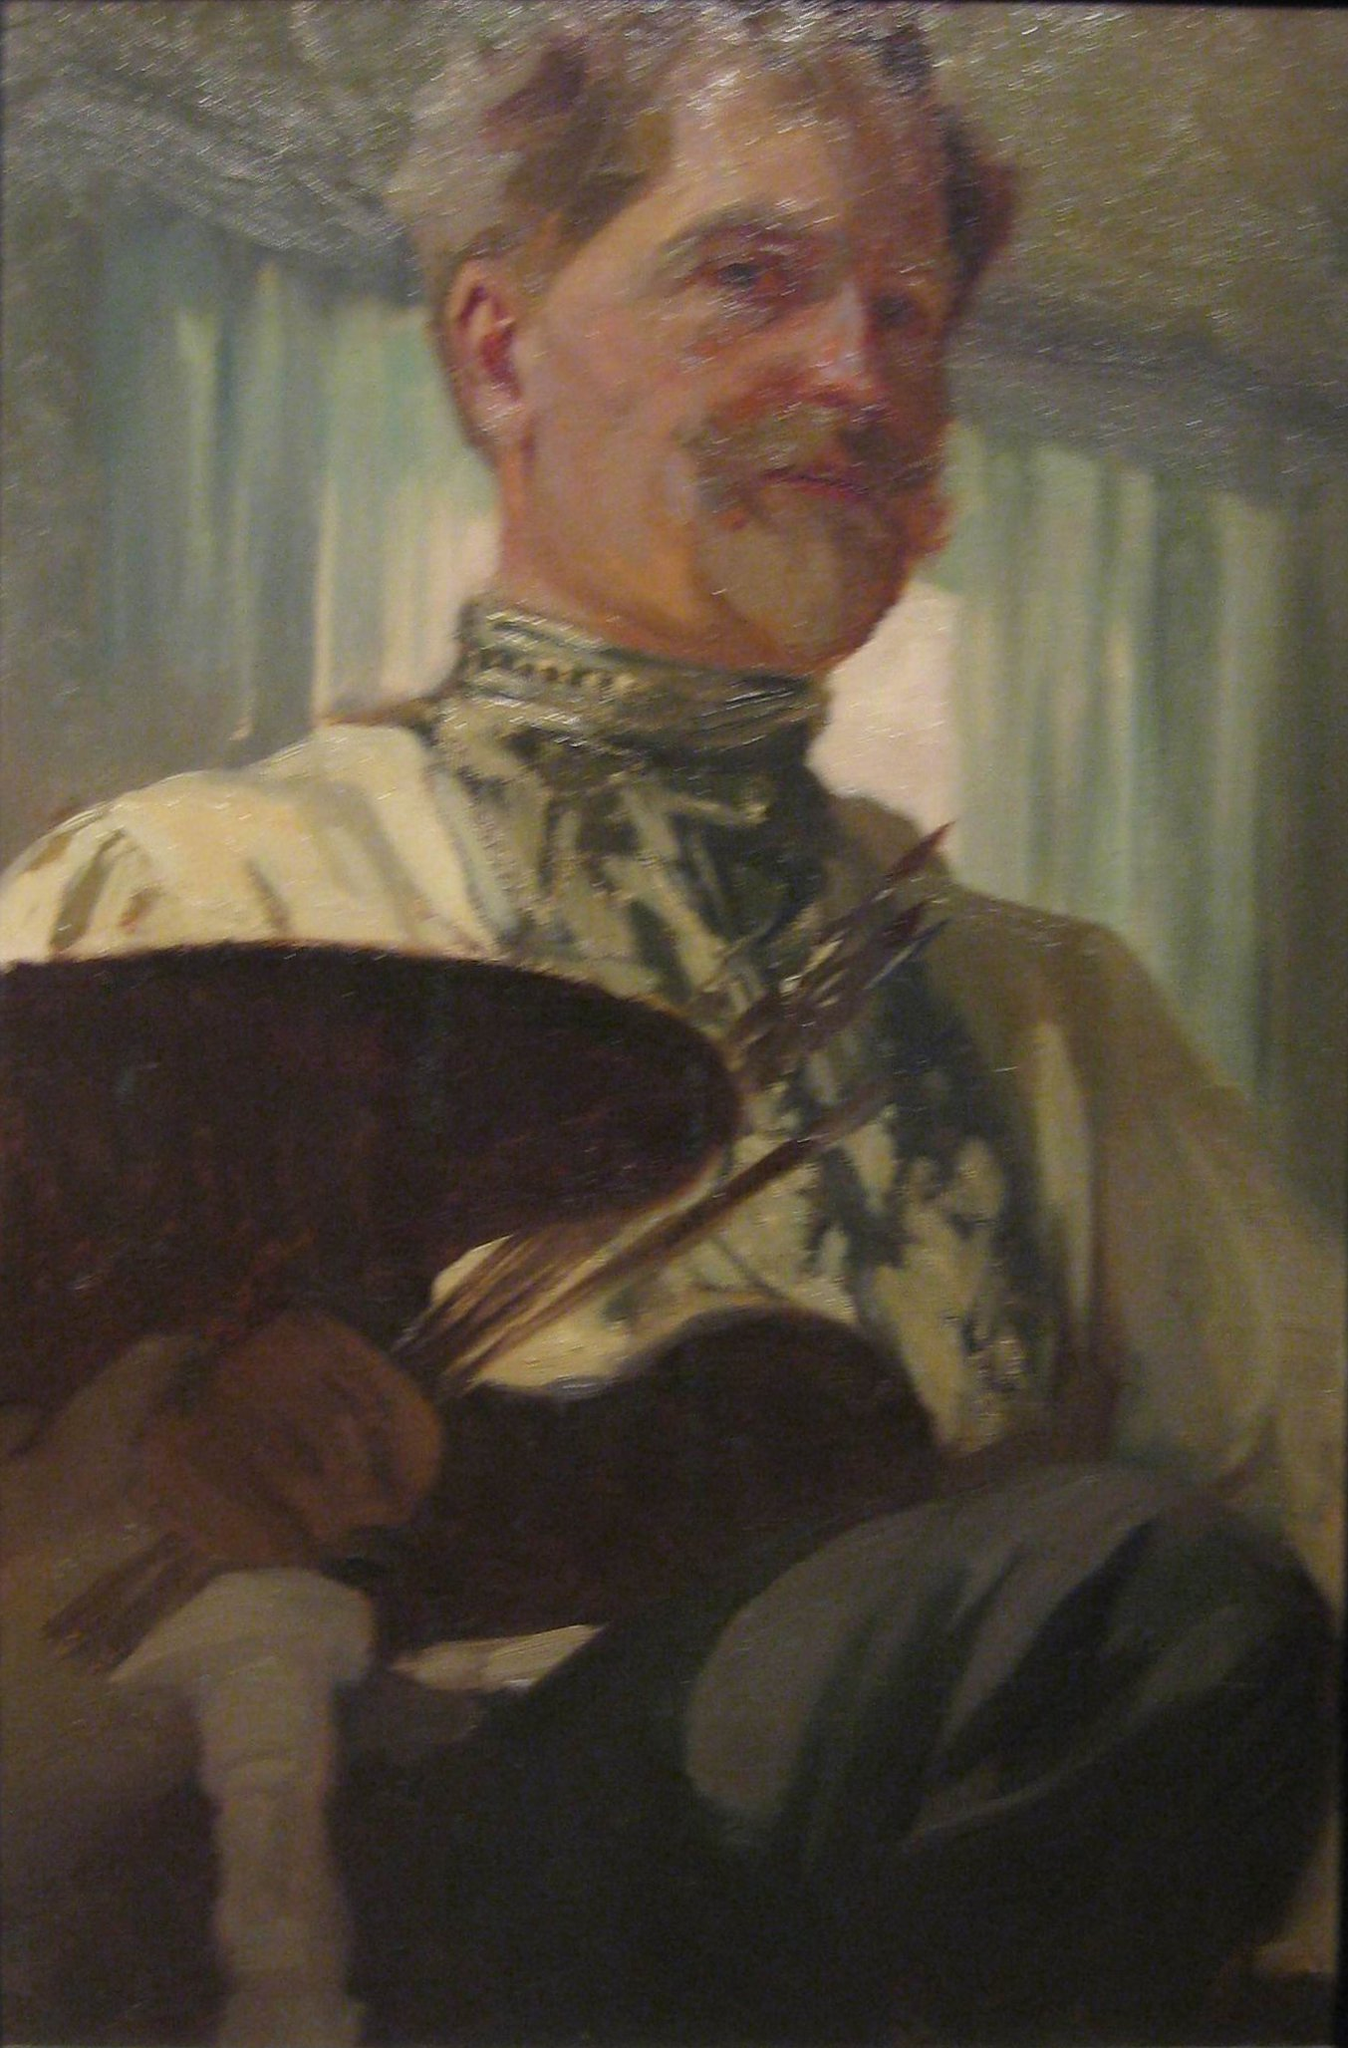Create a fictional backstory for the man in the painting, incorporating imaginative elements. In a quiet village nestled between rolling hills and a glistening river, lived a renowned artist named Elric Valtorius. Elric was not just a painter; he was a wizard of the canvas, able to bring his creations to life with a mere whisper of his brush. His smock, an heirloom passed down through generations, was said to be enchanted, absorbing the essence of every masterpiece he created. One particularly enchanting evening, as the moon cast its silver glow through the window, Elric embarked on his most ambitious creation yet – a portal to a realm of pure imagination. As he painted, the air around him shimmered with magic, and his eyes gleamed with the vision of hidden landscapes and fantastical beings. The curtain behind him swayed as if touched by unseen hands, and the colors on his palette glowed with an ethereal light. The village spoke of the day Elric’s masterpiece would open a gateway, allowing dreamers and adventurers to step into worlds beyond their wildest dreams, guided by the gentle hand of the artist himself in a realm where creativity knew no bounds. 